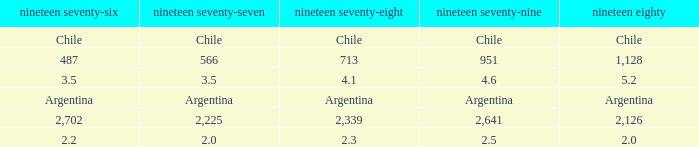What is 1980 when 1979 is 951? 1128.0. 